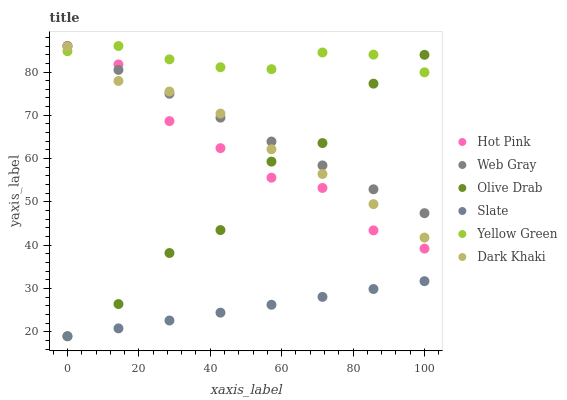Does Slate have the minimum area under the curve?
Answer yes or no. Yes. Does Yellow Green have the maximum area under the curve?
Answer yes or no. Yes. Does Yellow Green have the minimum area under the curve?
Answer yes or no. No. Does Slate have the maximum area under the curve?
Answer yes or no. No. Is Web Gray the smoothest?
Answer yes or no. Yes. Is Olive Drab the roughest?
Answer yes or no. Yes. Is Yellow Green the smoothest?
Answer yes or no. No. Is Yellow Green the roughest?
Answer yes or no. No. Does Slate have the lowest value?
Answer yes or no. Yes. Does Yellow Green have the lowest value?
Answer yes or no. No. Does Hot Pink have the highest value?
Answer yes or no. Yes. Does Slate have the highest value?
Answer yes or no. No. Is Slate less than Yellow Green?
Answer yes or no. Yes. Is Web Gray greater than Slate?
Answer yes or no. Yes. Does Olive Drab intersect Slate?
Answer yes or no. Yes. Is Olive Drab less than Slate?
Answer yes or no. No. Is Olive Drab greater than Slate?
Answer yes or no. No. Does Slate intersect Yellow Green?
Answer yes or no. No. 